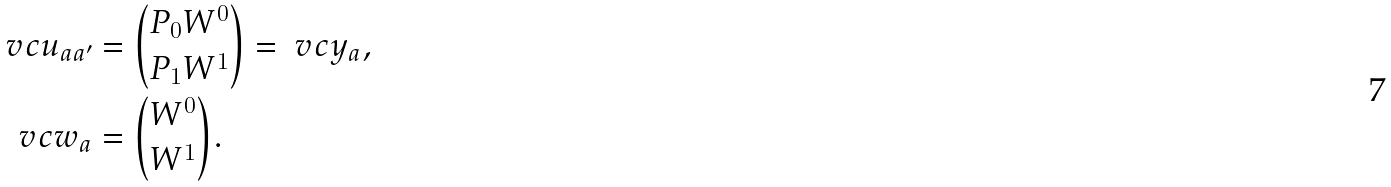<formula> <loc_0><loc_0><loc_500><loc_500>\ v c { u } _ { a a ^ { \prime } } & = { P _ { 0 } W ^ { 0 } \choose P _ { 1 } W ^ { 1 } } = \ v c { y } _ { a } , \\ \ v c { w } _ { a } & = { W ^ { 0 } \choose W ^ { 1 } } .</formula> 